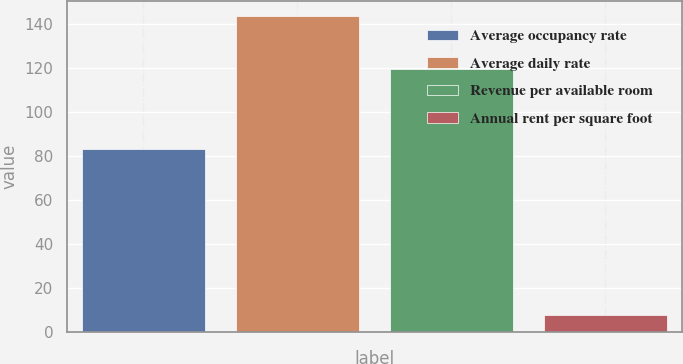<chart> <loc_0><loc_0><loc_500><loc_500><bar_chart><fcel>Average occupancy rate<fcel>Average daily rate<fcel>Revenue per available room<fcel>Annual rent per square foot<nl><fcel>83.2<fcel>143.28<fcel>119.23<fcel>7.52<nl></chart> 